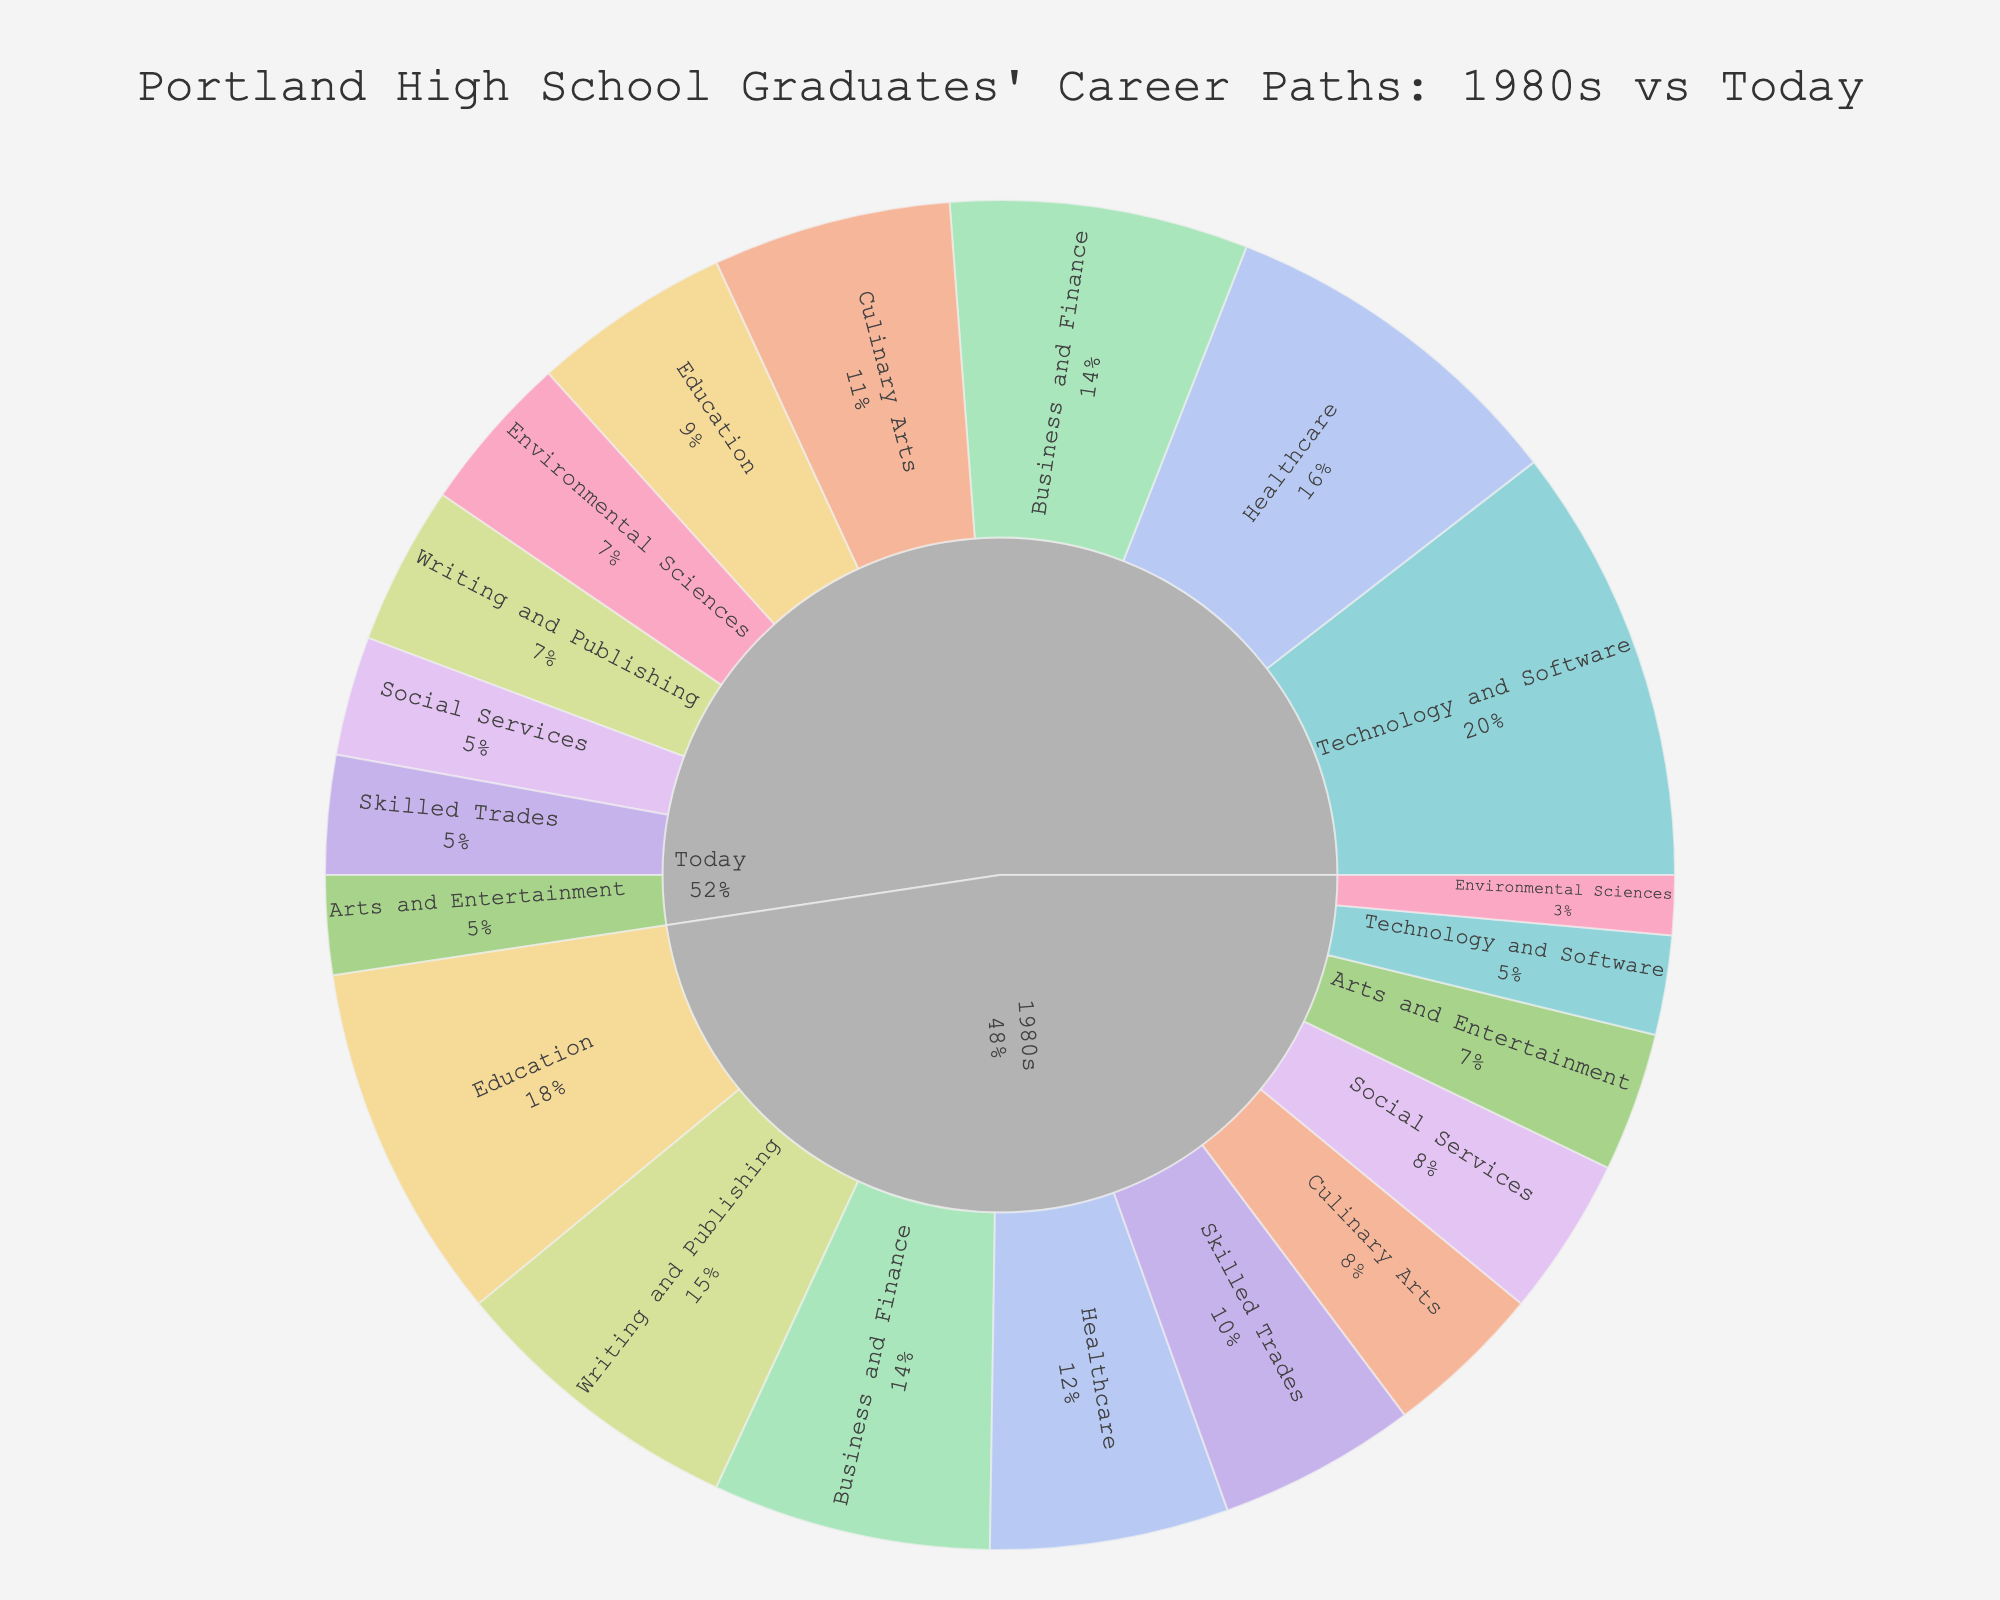What percentage of high school graduates pursued Technology and Software careers in the 1980s versus today? The figure shows different career paths in two periods: the 1980s and today. For each career path, the percentage of graduates is given. According to the data, Technology and Software comprises 5% in the 1980s and 22% today.
Answer: 5% in the 1980s, 22% today Which career path saw the largest increase in percentage from the 1980s to today? To determine which career path experienced the largest increase, calculate the difference in percentages for each career path. Technology and Software increased from 5% to 22%, a difference of 17%, which is the largest increase among all paths shown.
Answer: Technology and Software How many career paths had a higher percentage of graduates in the 1980s compared to today? Compare the percentages for both periods for each career path: Writing and Publishing (15% vs. 8%), Education (18% vs. 10%), Skilled Trades (10% vs. 6%), Arts and Entertainment (7% vs. 5%), Social Services (8% vs. 6%). Five career paths had higher percentages in the 1980s.
Answer: Five What is the sum of the percentages of graduates pursuing Culinary Arts and Environmental Sciences today? Look for the percentages of Culinary Arts (12%) and Environmental Sciences (8%) in today's data and add them: 12% + 8% = 20%.
Answer: 20% How did the percentage of graduates entering the Healthcare field change from the 1980s to today? To find the change, subtract the 1980s percentage from today's percentage: 18% (today) - 12% (1980s) = 6%. The percentage of graduates pursuing Healthcare increased by 6%.
Answer: Increased by 6% Which career path has an equal percentage of graduates in both the 1980s and today? Compare the percentages for each career path in the 1980s and today. Only Business and Finance have equal percentages: 14% in both periods.
Answer: Business and Finance What is the average percentage of graduates pursuing Education and Social Services in the 1980s? Calculate the average by adding the percentages (Education: 18%, Social Services: 8%) and dividing by 2: (18% + 8%) / 2 = 13%.
Answer: 13% Which career paths saw a decrease in the percentage of graduates from the 1980s to today, and what are the decreased percentages? Compare the percentages for each career path in both periods. Writing and Publishing (15% to 8%), Education (18% to 10%), Skilled Trades (10% to 6%), Arts and Entertainment (7% to 5%), and Social Services (8% to 6%) decreased. The decreases are 15%-8% = 7%, 18%-10% = 8%, 10%-6% = 4%, 7%-5% = 2%, and 8%-6% = 2%.
Answer: Writing and Publishing (7%), Education (8%), Skilled Trades (4%), Arts and Entertainment (2%), Social Services (2%) What is the difference in percentage for graduates pursuing Environmental Sciences between the 1980s and today, and is this path increasing or decreasing? Identify and subtract the percentages: 8% (today) - 3% (1980s) = 5%. Environmental Sciences is increasing by 5%.
Answer: Increasing by 5% By how much did the percentage of graduates pursuing Culinary Arts change from the 1980s to today? Subtract the 1980s percentage from the current percentage for Culinary Arts: 12% (today) - 8% (1980s) = 4%. The percentage increased by 4%.
Answer: Increased by 4% 